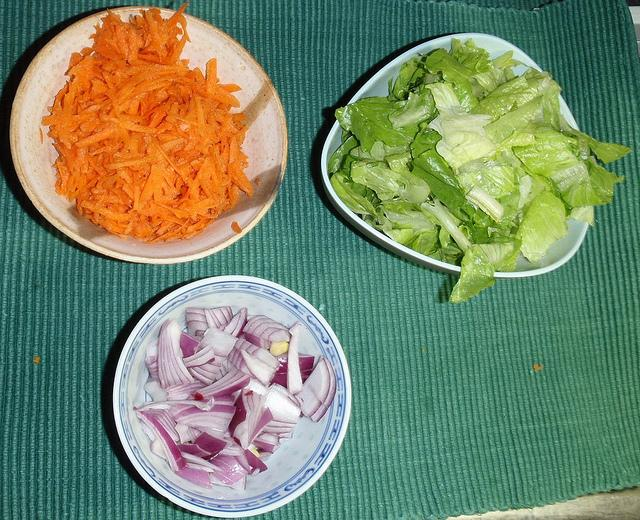What type of food are all of these? Please explain your reasoning. vegetables. There are three plates of food. one has onions, lettuce, and carrots on it. 